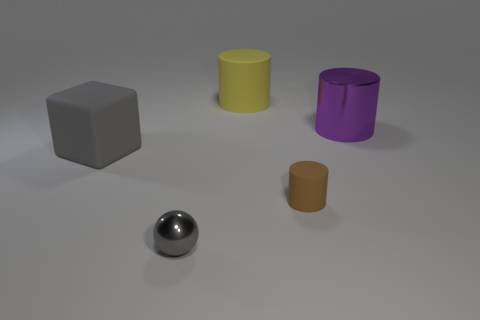Add 1 brown cylinders. How many objects exist? 6 Subtract all blocks. How many objects are left? 4 Add 1 tiny gray spheres. How many tiny gray spheres exist? 2 Subtract 0 green cylinders. How many objects are left? 5 Subtract all large shiny spheres. Subtract all brown matte cylinders. How many objects are left? 4 Add 1 purple shiny objects. How many purple shiny objects are left? 2 